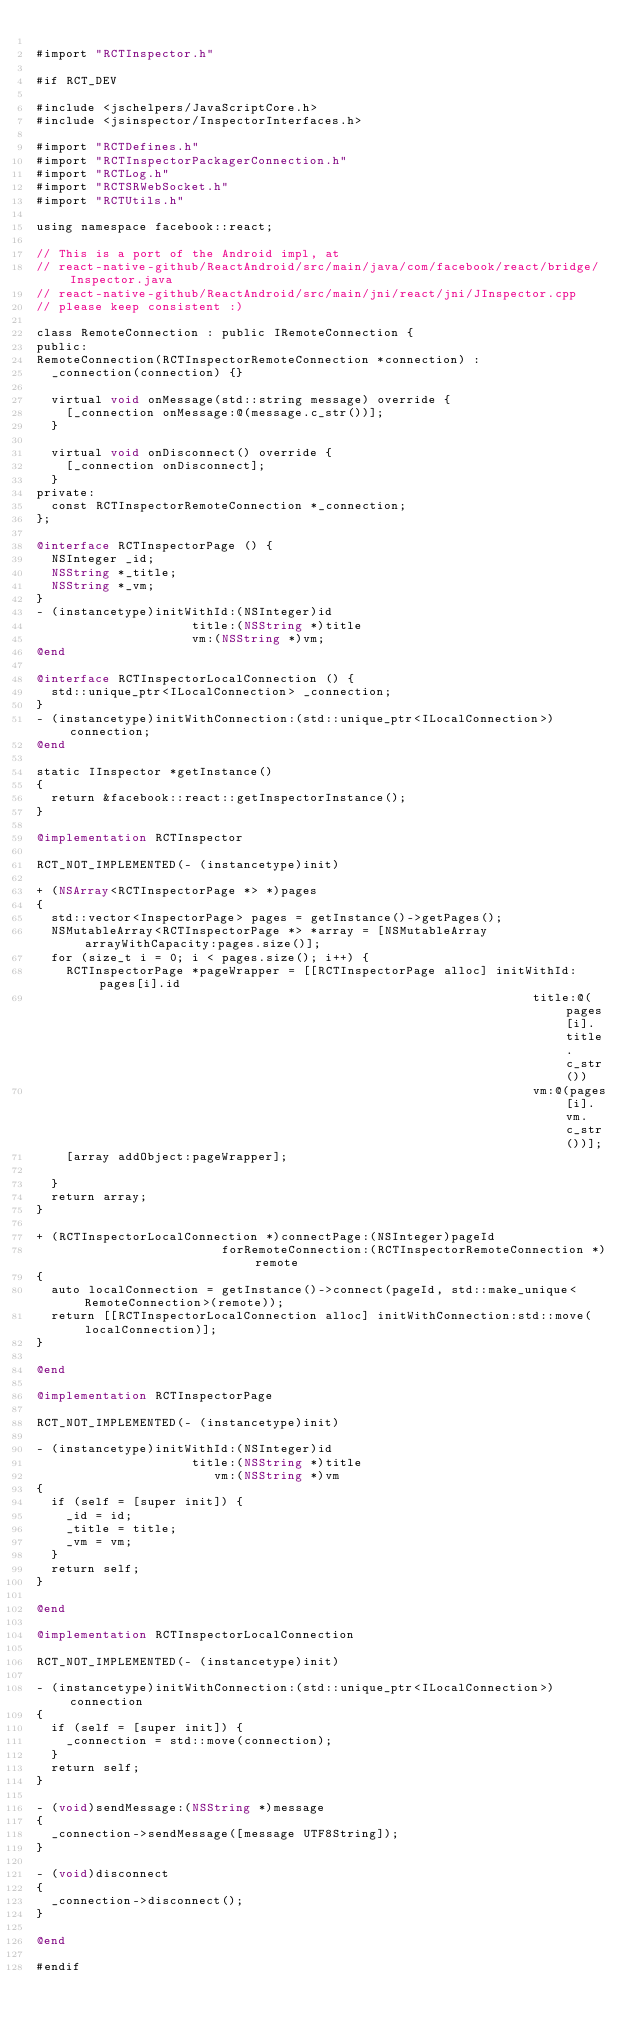Convert code to text. <code><loc_0><loc_0><loc_500><loc_500><_ObjectiveC_>
#import "RCTInspector.h"

#if RCT_DEV

#include <jschelpers/JavaScriptCore.h>
#include <jsinspector/InspectorInterfaces.h>

#import "RCTDefines.h"
#import "RCTInspectorPackagerConnection.h"
#import "RCTLog.h"
#import "RCTSRWebSocket.h"
#import "RCTUtils.h"

using namespace facebook::react;

// This is a port of the Android impl, at
// react-native-github/ReactAndroid/src/main/java/com/facebook/react/bridge/Inspector.java
// react-native-github/ReactAndroid/src/main/jni/react/jni/JInspector.cpp
// please keep consistent :)

class RemoteConnection : public IRemoteConnection {
public:
RemoteConnection(RCTInspectorRemoteConnection *connection) :
  _connection(connection) {}

  virtual void onMessage(std::string message) override {
    [_connection onMessage:@(message.c_str())];
  }

  virtual void onDisconnect() override {
    [_connection onDisconnect];
  }
private:
  const RCTInspectorRemoteConnection *_connection;
};

@interface RCTInspectorPage () {
  NSInteger _id;
  NSString *_title;
  NSString *_vm;
}
- (instancetype)initWithId:(NSInteger)id
                     title:(NSString *)title
                     vm:(NSString *)vm;
@end

@interface RCTInspectorLocalConnection () {
  std::unique_ptr<ILocalConnection> _connection;
}
- (instancetype)initWithConnection:(std::unique_ptr<ILocalConnection>)connection;
@end

static IInspector *getInstance()
{
  return &facebook::react::getInspectorInstance();
}

@implementation RCTInspector

RCT_NOT_IMPLEMENTED(- (instancetype)init)

+ (NSArray<RCTInspectorPage *> *)pages
{
  std::vector<InspectorPage> pages = getInstance()->getPages();
  NSMutableArray<RCTInspectorPage *> *array = [NSMutableArray arrayWithCapacity:pages.size()];
  for (size_t i = 0; i < pages.size(); i++) {
    RCTInspectorPage *pageWrapper = [[RCTInspectorPage alloc] initWithId:pages[i].id
                                                                   title:@(pages[i].title.c_str())
                                                                   vm:@(pages[i].vm.c_str())];
    [array addObject:pageWrapper];

  }
  return array;
}

+ (RCTInspectorLocalConnection *)connectPage:(NSInteger)pageId
                         forRemoteConnection:(RCTInspectorRemoteConnection *)remote
{
  auto localConnection = getInstance()->connect(pageId, std::make_unique<RemoteConnection>(remote));
  return [[RCTInspectorLocalConnection alloc] initWithConnection:std::move(localConnection)];
}

@end

@implementation RCTInspectorPage

RCT_NOT_IMPLEMENTED(- (instancetype)init)

- (instancetype)initWithId:(NSInteger)id
                     title:(NSString *)title
                        vm:(NSString *)vm
{
  if (self = [super init]) {
    _id = id;
    _title = title;
    _vm = vm;
  }
  return self;
}

@end

@implementation RCTInspectorLocalConnection

RCT_NOT_IMPLEMENTED(- (instancetype)init)

- (instancetype)initWithConnection:(std::unique_ptr<ILocalConnection>)connection
{
  if (self = [super init]) {
    _connection = std::move(connection);
  }
  return self;
}

- (void)sendMessage:(NSString *)message
{
  _connection->sendMessage([message UTF8String]);
}

- (void)disconnect
{
  _connection->disconnect();
}

@end

#endif
</code> 